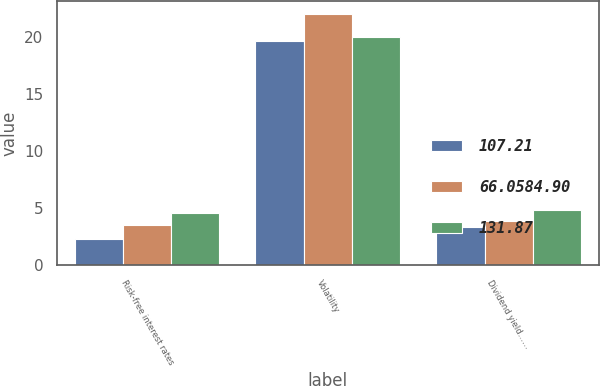Convert chart to OTSL. <chart><loc_0><loc_0><loc_500><loc_500><stacked_bar_chart><ecel><fcel>Risk-free interest rates<fcel>Volatility<fcel>Dividend yield……<nl><fcel>107.21<fcel>2.23<fcel>19.63<fcel>3.29<nl><fcel>66.0584.90<fcel>3.5<fcel>22<fcel>3.85<nl><fcel>131.87<fcel>4.58<fcel>20<fcel>4.85<nl></chart> 